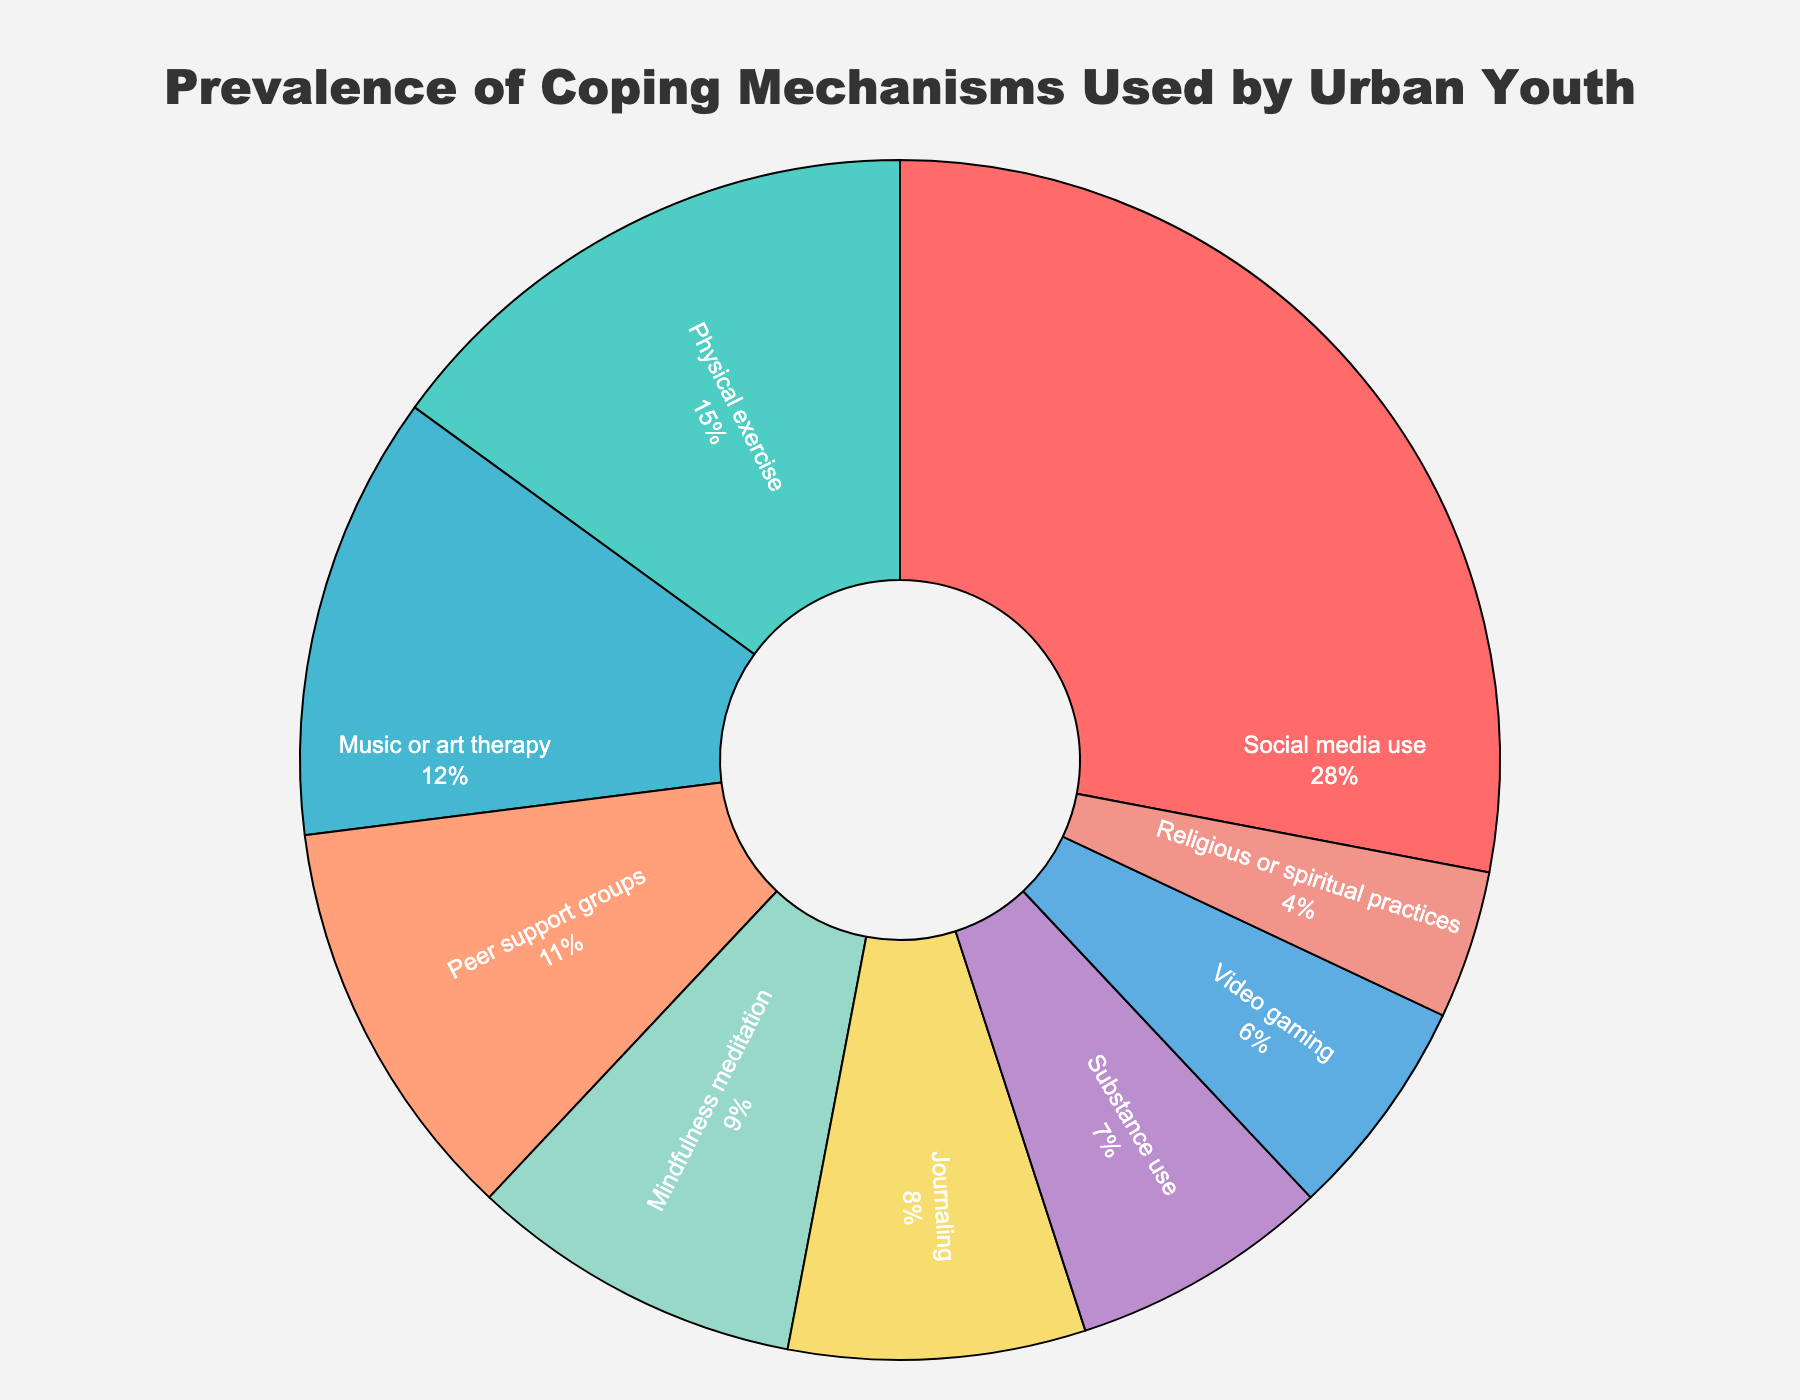what is the combined percentage of music or art therapy and journaling? First, find the percentages for music or art therapy (12%) and journaling (8%). Then, sum them: 12% + 8% = 20%
Answer: 20% which coping mechanism has the second highest prevalence? By looking at the sorted sections in the pie chart, the second largest slice corresponds to physical exercise with 15%.
Answer: Physical exercise how does the prevalence of peer support groups compare to mindfulness meditation? Peer support groups have a prevalence of 11%, while mindfulness meditation has a prevalence of 9%. Thus, peer support groups have a higher prevalence.
Answer: Peer support groups have a higher prevalence than mindfulness meditation what is the percentage difference between substance use and video gaming? Substance use has a prevalence of 7% and video gaming has a prevalence of 6%. The percentage difference is calculated as 7% - 6% = 1%.
Answer: 1% which coping mechanism represents the smallest portion in the pie chart? The smallest portion in the pie chart corresponds to religious or spiritual practices, which have a prevalence of 4%.
Answer: Religious or spiritual practices what is the total percentage of coping mechanisms that involve group or community activities? The group or community activities are peer support groups (11%) and religious or spiritual practices (4%). Sum these percentages: 11% + 4% = 15%.
Answer: 15% which color represents journaling and what is its percentage in the pie chart? The slice corresponding to journaling is marked in pink color, which is associated with 8%.
Answer: Pink, 8% is there a significant gap between the most and least prevalent coping mechanisms? The most prevalent coping mechanism is social media use at 28% and the least prevalent is religious or spiritual practices at 4%. The gap can be calculated as 28% - 4% = 24%.
Answer: Yes, there is a 24% gap what coping mechanisms make up for more than 50% when combined? Combining the top coping mechanisms: Social media use (28%), physical exercise (15%), and music or art therapy (12%) gives a total of 28% + 15% + 12% = 55%.
Answer: Social media use, physical exercise, music or art therapy 